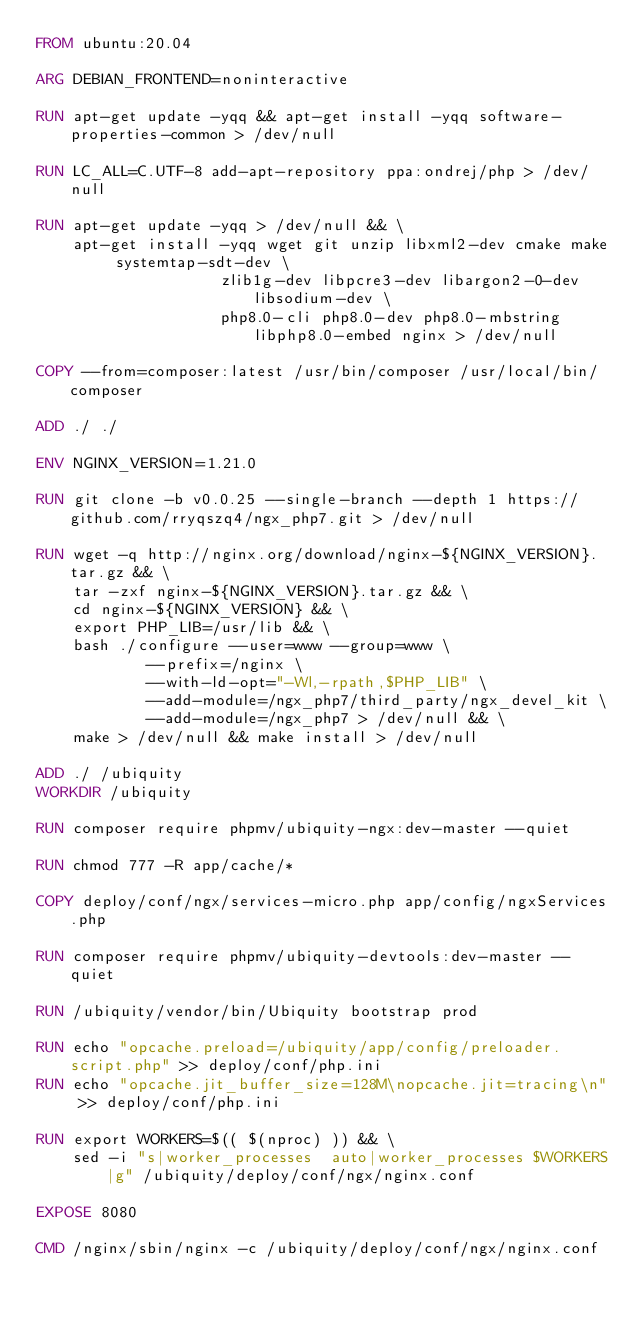<code> <loc_0><loc_0><loc_500><loc_500><_Dockerfile_>FROM ubuntu:20.04

ARG DEBIAN_FRONTEND=noninteractive

RUN apt-get update -yqq && apt-get install -yqq software-properties-common > /dev/null

RUN LC_ALL=C.UTF-8 add-apt-repository ppa:ondrej/php > /dev/null

RUN apt-get update -yqq > /dev/null && \
    apt-get install -yqq wget git unzip libxml2-dev cmake make systemtap-sdt-dev \
                    zlib1g-dev libpcre3-dev libargon2-0-dev libsodium-dev \
                    php8.0-cli php8.0-dev php8.0-mbstring libphp8.0-embed nginx > /dev/null

COPY --from=composer:latest /usr/bin/composer /usr/local/bin/composer

ADD ./ ./

ENV NGINX_VERSION=1.21.0

RUN git clone -b v0.0.25 --single-branch --depth 1 https://github.com/rryqszq4/ngx_php7.git > /dev/null

RUN wget -q http://nginx.org/download/nginx-${NGINX_VERSION}.tar.gz && \
    tar -zxf nginx-${NGINX_VERSION}.tar.gz && \
    cd nginx-${NGINX_VERSION} && \
    export PHP_LIB=/usr/lib && \
    bash ./configure --user=www --group=www \
            --prefix=/nginx \
            --with-ld-opt="-Wl,-rpath,$PHP_LIB" \
            --add-module=/ngx_php7/third_party/ngx_devel_kit \
            --add-module=/ngx_php7 > /dev/null && \
    make > /dev/null && make install > /dev/null

ADD ./ /ubiquity
WORKDIR /ubiquity

RUN composer require phpmv/ubiquity-ngx:dev-master --quiet

RUN chmod 777 -R app/cache/*

COPY deploy/conf/ngx/services-micro.php app/config/ngxServices.php

RUN composer require phpmv/ubiquity-devtools:dev-master --quiet

RUN /ubiquity/vendor/bin/Ubiquity bootstrap prod

RUN echo "opcache.preload=/ubiquity/app/config/preloader.script.php" >> deploy/conf/php.ini
RUN echo "opcache.jit_buffer_size=128M\nopcache.jit=tracing\n" >> deploy/conf/php.ini

RUN export WORKERS=$(( $(nproc) )) && \
    sed -i "s|worker_processes  auto|worker_processes $WORKERS|g" /ubiquity/deploy/conf/ngx/nginx.conf

EXPOSE 8080

CMD /nginx/sbin/nginx -c /ubiquity/deploy/conf/ngx/nginx.conf
</code> 